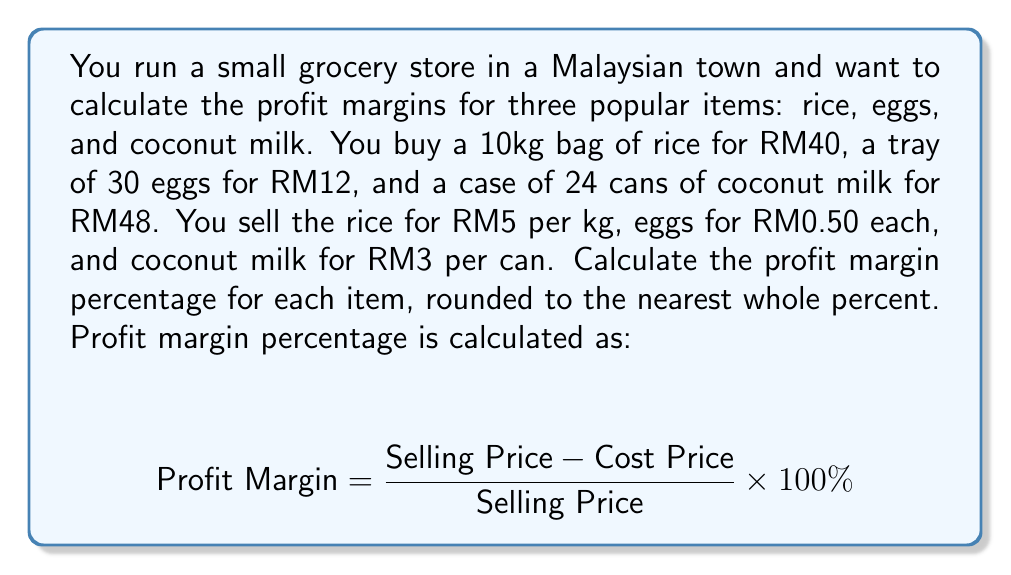Show me your answer to this math problem. Let's calculate the profit margin for each item:

1. Rice:
   - Cost price per kg: RM40 / 10kg = RM4/kg
   - Selling price per kg: RM5/kg
   - Profit margin: $\frac{5 - 4}{5} \times 100\% = \frac{1}{5} \times 100\% = 20\%$

2. Eggs:
   - Cost price per egg: RM12 / 30 = RM0.40/egg
   - Selling price per egg: RM0.50/egg
   - Profit margin: $\frac{0.50 - 0.40}{0.50} \times 100\% = \frac{0.10}{0.50} \times 100\% = 20\%$

3. Coconut milk:
   - Cost price per can: RM48 / 24 = RM2/can
   - Selling price per can: RM3/can
   - Profit margin: $\frac{3 - 2}{3} \times 100\% = \frac{1}{3} \times 100\% \approx 33\%$

Rounding to the nearest whole percent:
- Rice: 20%
- Eggs: 20%
- Coconut milk: 33%
Answer: Rice: 20%, Eggs: 20%, Coconut milk: 33% 